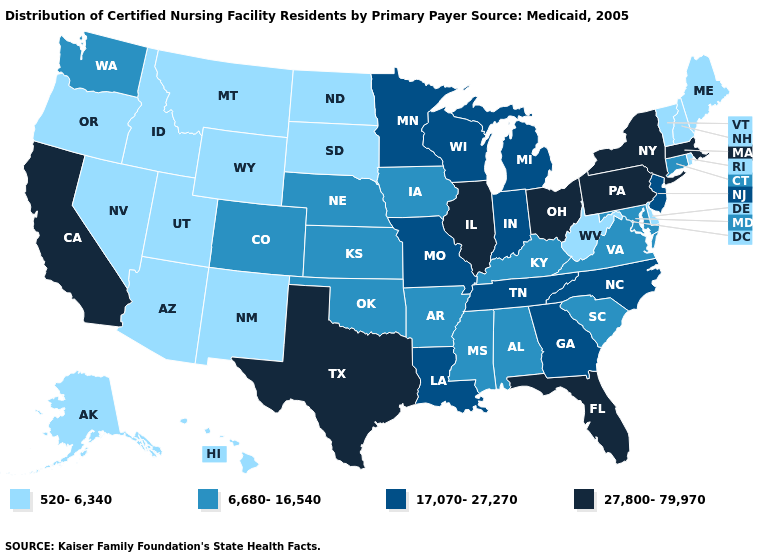What is the highest value in the West ?
Give a very brief answer. 27,800-79,970. Name the states that have a value in the range 520-6,340?
Answer briefly. Alaska, Arizona, Delaware, Hawaii, Idaho, Maine, Montana, Nevada, New Hampshire, New Mexico, North Dakota, Oregon, Rhode Island, South Dakota, Utah, Vermont, West Virginia, Wyoming. Does the map have missing data?
Quick response, please. No. Which states have the lowest value in the USA?
Concise answer only. Alaska, Arizona, Delaware, Hawaii, Idaho, Maine, Montana, Nevada, New Hampshire, New Mexico, North Dakota, Oregon, Rhode Island, South Dakota, Utah, Vermont, West Virginia, Wyoming. What is the value of Kansas?
Be succinct. 6,680-16,540. What is the value of Michigan?
Concise answer only. 17,070-27,270. Among the states that border Vermont , does New Hampshire have the lowest value?
Keep it brief. Yes. Does Nebraska have the same value as Iowa?
Short answer required. Yes. What is the value of Louisiana?
Write a very short answer. 17,070-27,270. Name the states that have a value in the range 27,800-79,970?
Quick response, please. California, Florida, Illinois, Massachusetts, New York, Ohio, Pennsylvania, Texas. Which states have the lowest value in the MidWest?
Write a very short answer. North Dakota, South Dakota. Name the states that have a value in the range 6,680-16,540?
Quick response, please. Alabama, Arkansas, Colorado, Connecticut, Iowa, Kansas, Kentucky, Maryland, Mississippi, Nebraska, Oklahoma, South Carolina, Virginia, Washington. Does the first symbol in the legend represent the smallest category?
Short answer required. Yes. What is the highest value in the South ?
Answer briefly. 27,800-79,970. Name the states that have a value in the range 17,070-27,270?
Concise answer only. Georgia, Indiana, Louisiana, Michigan, Minnesota, Missouri, New Jersey, North Carolina, Tennessee, Wisconsin. 